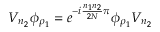Convert formula to latex. <formula><loc_0><loc_0><loc_500><loc_500>V _ { n _ { 2 } } \phi _ { \rho _ { 1 } } = e ^ { - i \frac { n _ { 1 } n _ { 2 } } { 2 N } \pi } \phi _ { \rho _ { 1 } } V _ { n _ { 2 } }</formula> 